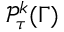<formula> <loc_0><loc_0><loc_500><loc_500>{ \mathcal { P } } _ { \tau } ^ { k } ( \Gamma )</formula> 